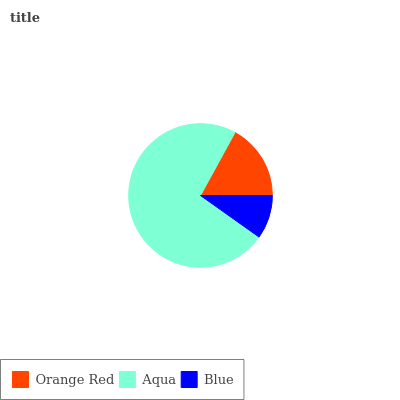Is Blue the minimum?
Answer yes or no. Yes. Is Aqua the maximum?
Answer yes or no. Yes. Is Aqua the minimum?
Answer yes or no. No. Is Blue the maximum?
Answer yes or no. No. Is Aqua greater than Blue?
Answer yes or no. Yes. Is Blue less than Aqua?
Answer yes or no. Yes. Is Blue greater than Aqua?
Answer yes or no. No. Is Aqua less than Blue?
Answer yes or no. No. Is Orange Red the high median?
Answer yes or no. Yes. Is Orange Red the low median?
Answer yes or no. Yes. Is Aqua the high median?
Answer yes or no. No. Is Blue the low median?
Answer yes or no. No. 